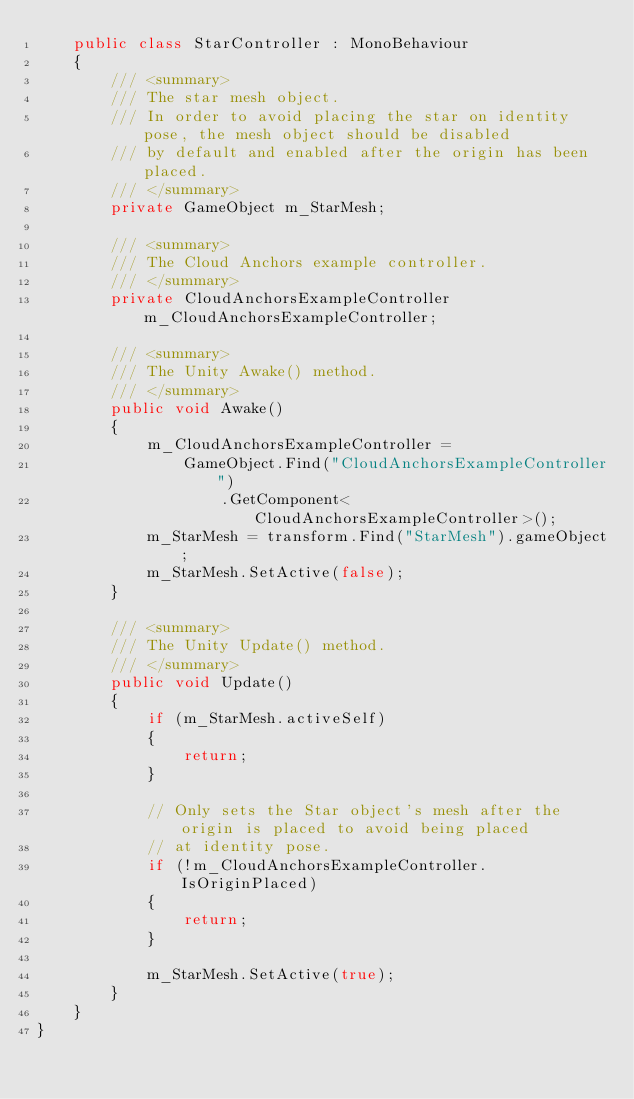<code> <loc_0><loc_0><loc_500><loc_500><_C#_>    public class StarController : MonoBehaviour
    {
        /// <summary>
        /// The star mesh object.
        /// In order to avoid placing the star on identity pose, the mesh object should be disabled
        /// by default and enabled after the origin has been placed.
        /// </summary>
        private GameObject m_StarMesh;

        /// <summary>
        /// The Cloud Anchors example controller.
        /// </summary>
        private CloudAnchorsExampleController m_CloudAnchorsExampleController;

        /// <summary>
        /// The Unity Awake() method.
        /// </summary>
        public void Awake()
        {
            m_CloudAnchorsExampleController =
                GameObject.Find("CloudAnchorsExampleController")
                    .GetComponent<CloudAnchorsExampleController>();
            m_StarMesh = transform.Find("StarMesh").gameObject;
            m_StarMesh.SetActive(false);
        }

        /// <summary>
        /// The Unity Update() method.
        /// </summary>
        public void Update()
        {
            if (m_StarMesh.activeSelf)
            {
                return;
            }

            // Only sets the Star object's mesh after the origin is placed to avoid being placed
            // at identity pose.
            if (!m_CloudAnchorsExampleController.IsOriginPlaced)
            {
                return;
            }

            m_StarMesh.SetActive(true);
        }
    }
}
</code> 